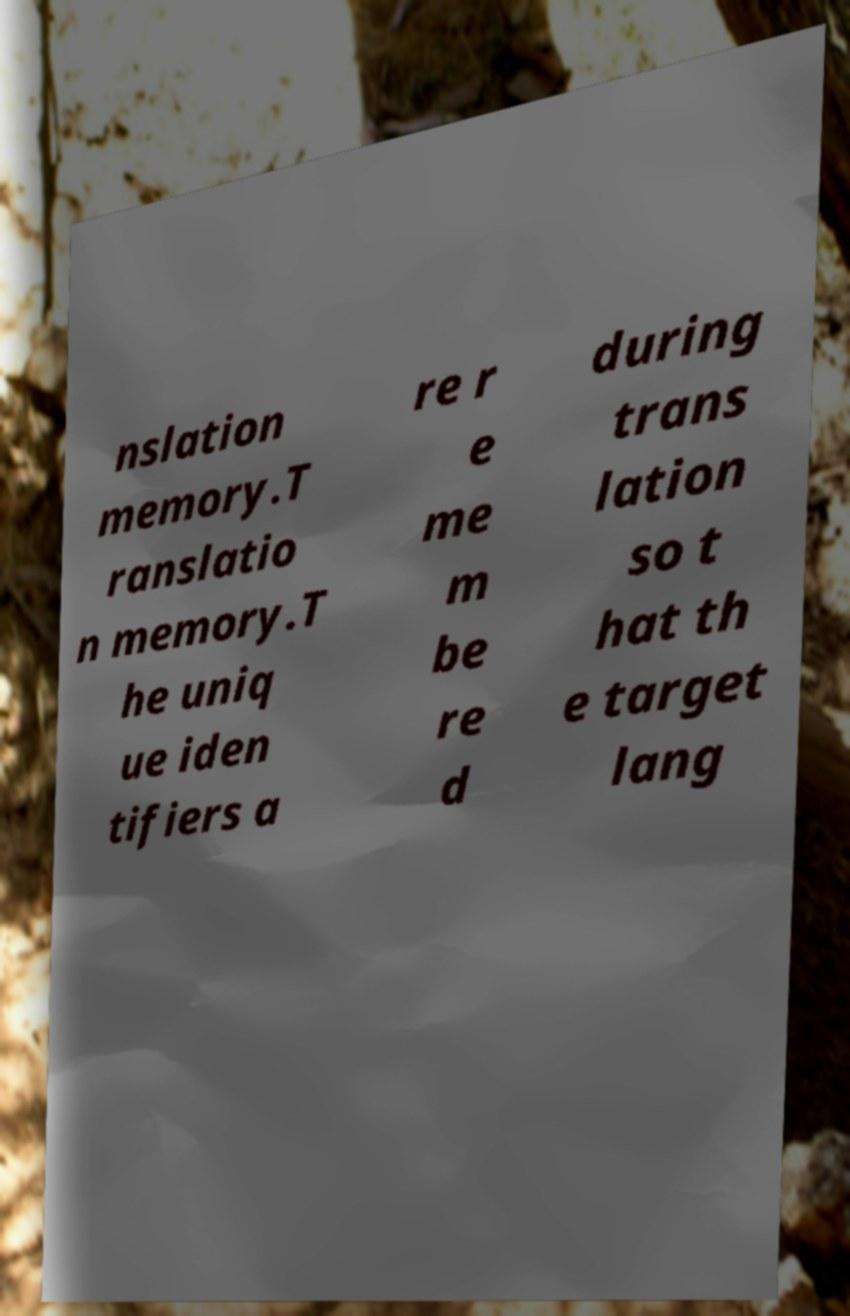Please read and relay the text visible in this image. What does it say? nslation memory.T ranslatio n memory.T he uniq ue iden tifiers a re r e me m be re d during trans lation so t hat th e target lang 